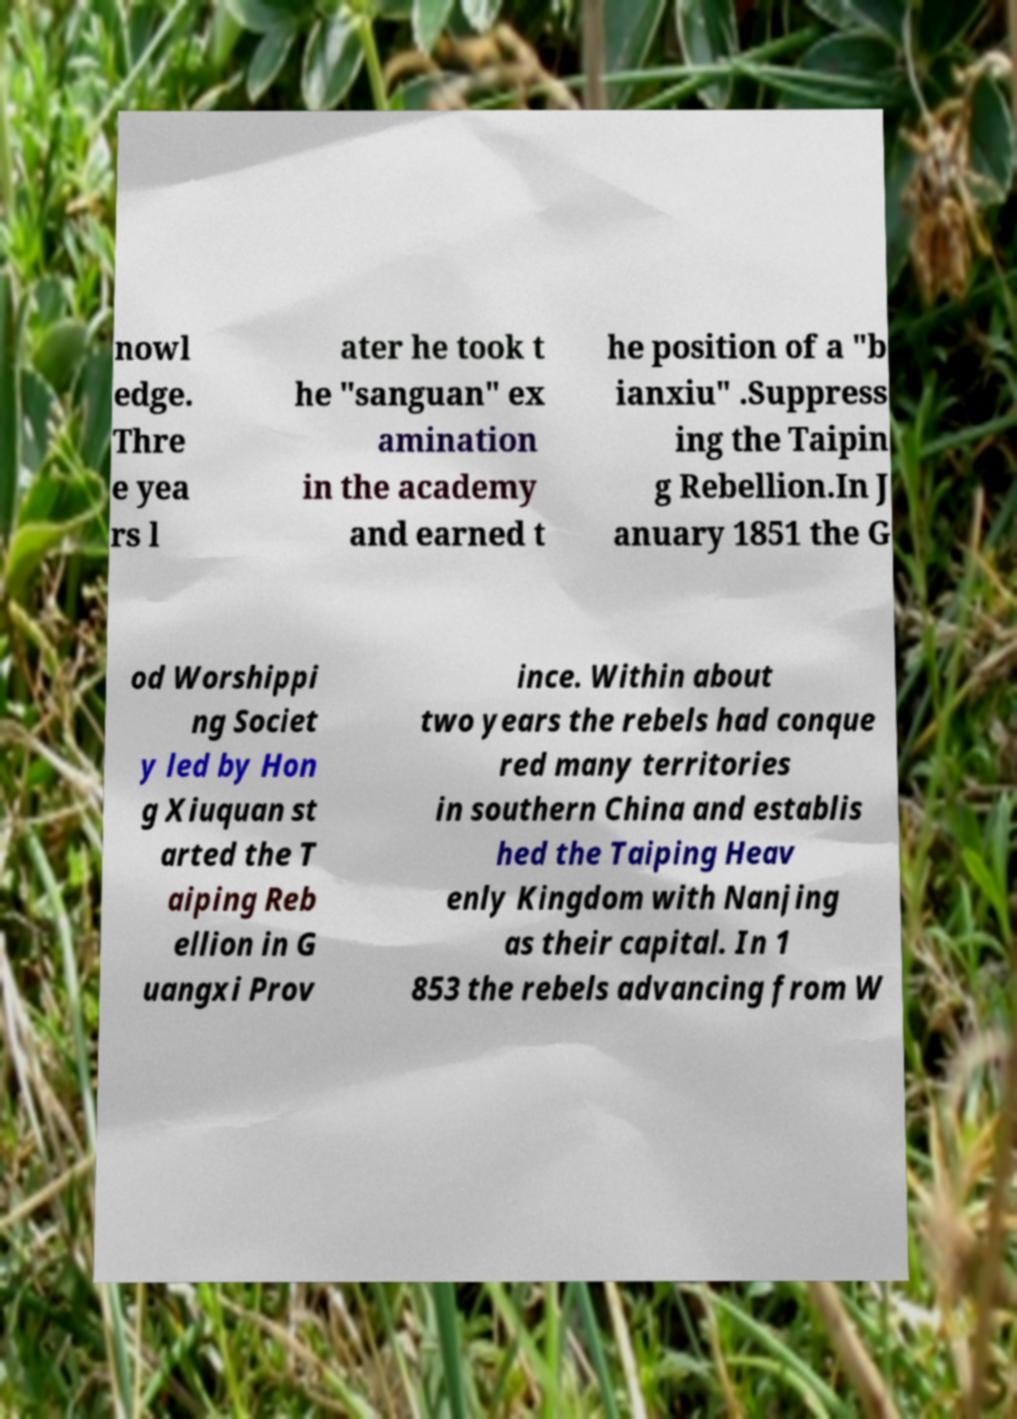I need the written content from this picture converted into text. Can you do that? nowl edge. Thre e yea rs l ater he took t he "sanguan" ex amination in the academy and earned t he position of a "b ianxiu" .Suppress ing the Taipin g Rebellion.In J anuary 1851 the G od Worshippi ng Societ y led by Hon g Xiuquan st arted the T aiping Reb ellion in G uangxi Prov ince. Within about two years the rebels had conque red many territories in southern China and establis hed the Taiping Heav enly Kingdom with Nanjing as their capital. In 1 853 the rebels advancing from W 